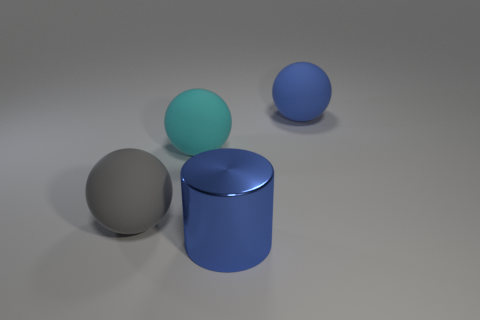What number of other things are the same color as the cylinder?
Your answer should be very brief. 1. Are the gray thing and the big blue object left of the blue matte sphere made of the same material?
Your answer should be very brief. No. There is a large ball right of the thing in front of the big gray rubber thing; how many cyan rubber things are in front of it?
Your answer should be compact. 1. Are there fewer large spheres behind the cyan matte ball than spheres that are behind the big gray matte thing?
Offer a terse response. Yes. What number of other things are there of the same material as the blue cylinder
Your answer should be very brief. 0. There is a cyan thing that is the same size as the gray sphere; what is its material?
Your response must be concise. Rubber. How many blue objects are either big metallic objects or small things?
Make the answer very short. 1. There is a large object that is on the right side of the large gray rubber thing and in front of the cyan rubber ball; what color is it?
Provide a short and direct response. Blue. Is the material of the object on the right side of the blue cylinder the same as the big cylinder in front of the cyan object?
Provide a succinct answer. No. Is the number of large shiny things that are in front of the large blue ball greater than the number of big gray things left of the gray rubber thing?
Offer a very short reply. Yes. 